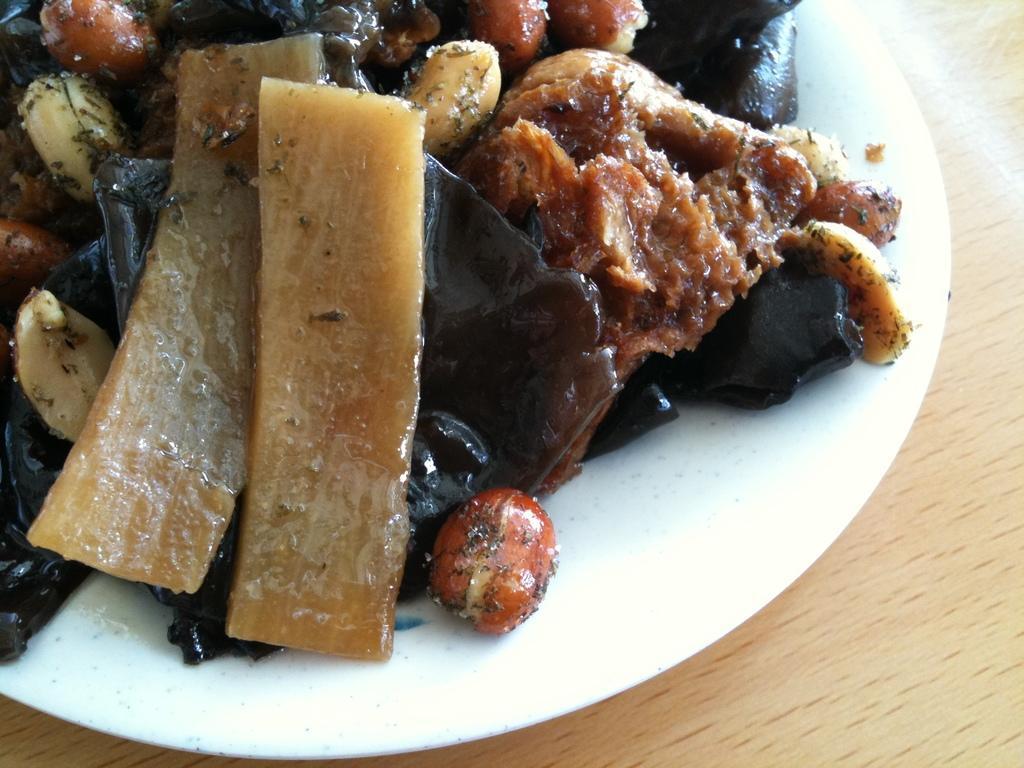Can you describe this image briefly? In the image on the wooden surface there is a plate with food items like peanuts and some other things in it. 